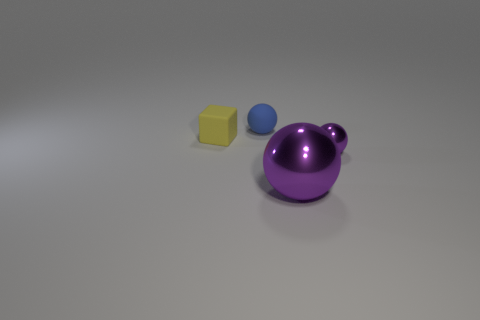If these objects were part of a game, what sort of game do you think it would be? If these objects were part of a game, it could be a sorting or matching game, where the goal is to categorize objects by color, shape, or size. The unique shapes and distinct colors lend themselves well to a game that requires visual discernment and classification skills. 